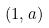<formula> <loc_0><loc_0><loc_500><loc_500>( 1 , a )</formula> 